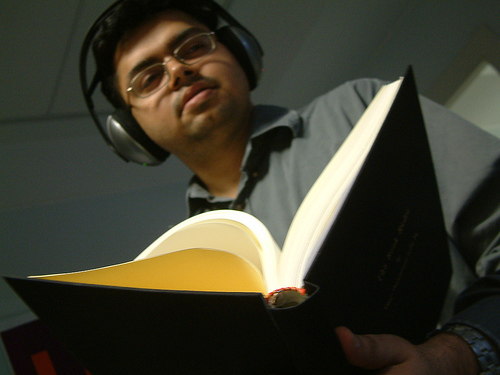<image>
Is the headphones on the book? No. The headphones is not positioned on the book. They may be near each other, but the headphones is not supported by or resting on top of the book. Where is the person in relation to the book? Is it to the right of the book? No. The person is not to the right of the book. The horizontal positioning shows a different relationship. 